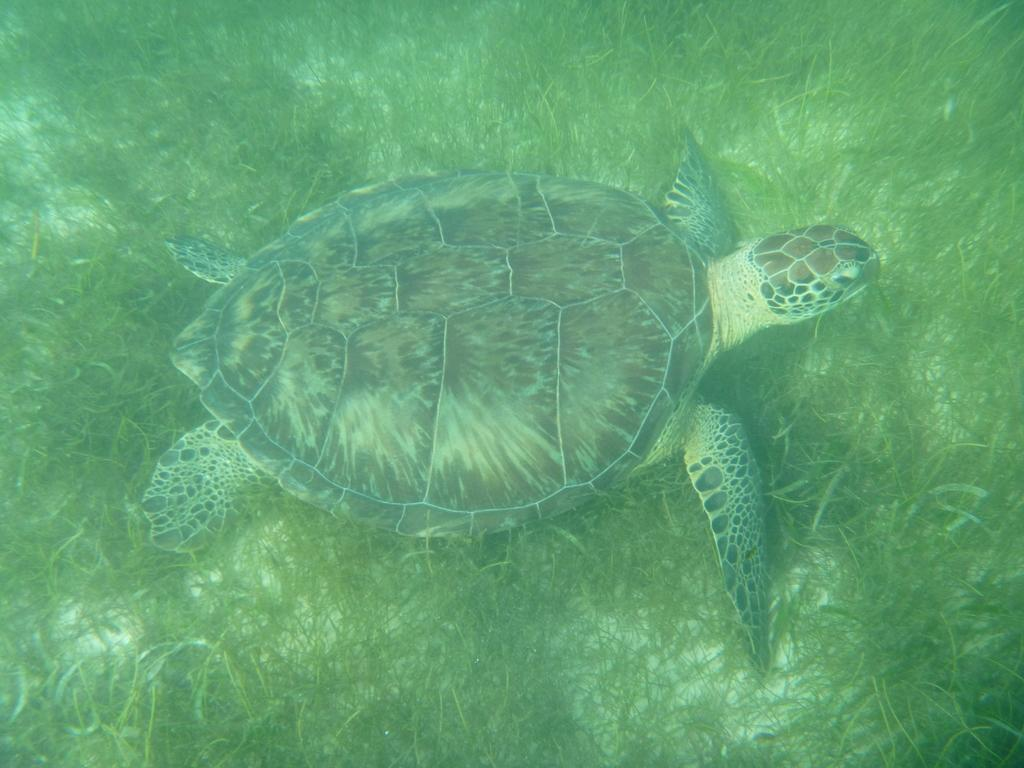What type of animal is in the image? There is a tortoise in the image. What type of vegetation is present in the image? There is grass throughout the image. What color is the sock that the tortoise is wearing in the image? There is no sock present in the image, as tortoises do not wear clothing. 